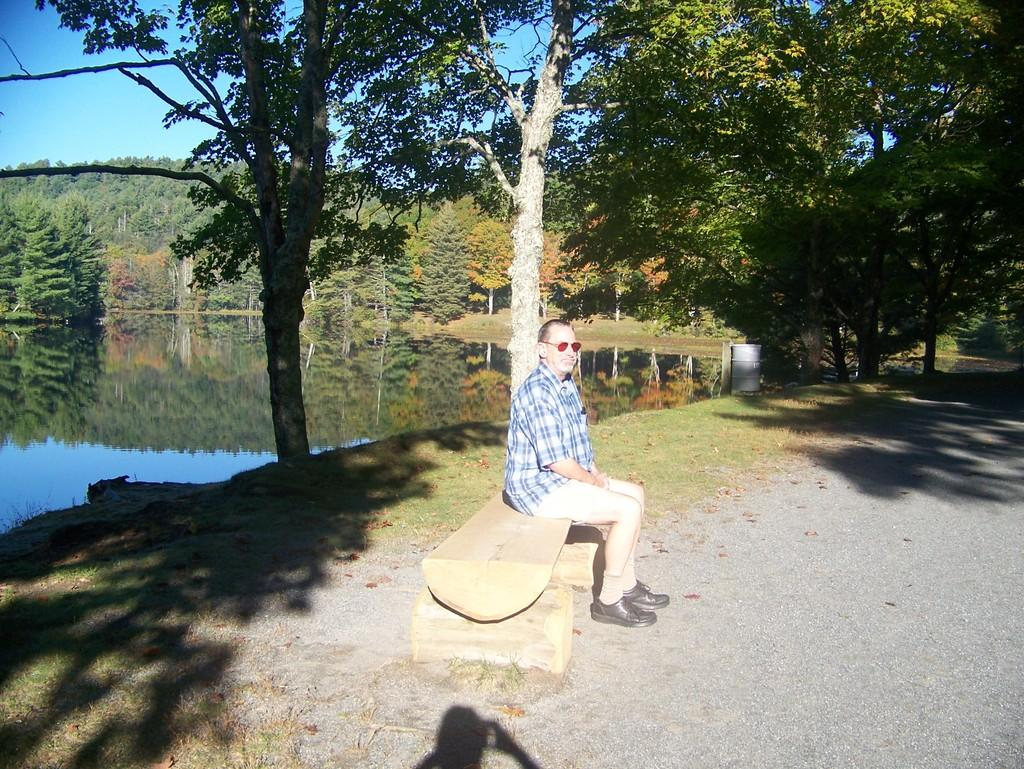What is the person in the image doing? There is a person sitting on a bench in the image. What can be seen in the background of the image? There are trees visible in the background of the image. What is located on the left side of the image? There is water on the left side of the image. How much salt is present in the water on the left side of the image? There is no information about the salt content in the water, and therefore it cannot be determined from the image. 